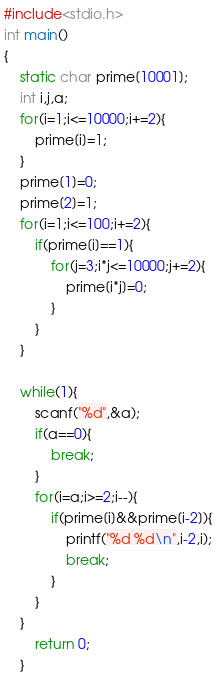<code> <loc_0><loc_0><loc_500><loc_500><_C_>#include<stdio.h>
int main()
{
	static char prime[10001];
	int i,j,a;
	for(i=1;i<=10000;i+=2){
		prime[i]=1;
	}
	prime[1]=0;
	prime[2]=1;
	for(i=1;i<=100;i+=2){
		if(prime[i]==1){
			for(j=3;i*j<=10000;j+=2){
				prime[i*j]=0;
			}
		}
	}
	
	while(1){
		scanf("%d",&a);
		if(a==0){
			break;
		}
		for(i=a;i>=2;i--){
			if(prime[i]&&prime[i-2]){
				printf("%d %d\n",i-2,i);
				break;
			}
		}
	}
		return 0;
	}</code> 